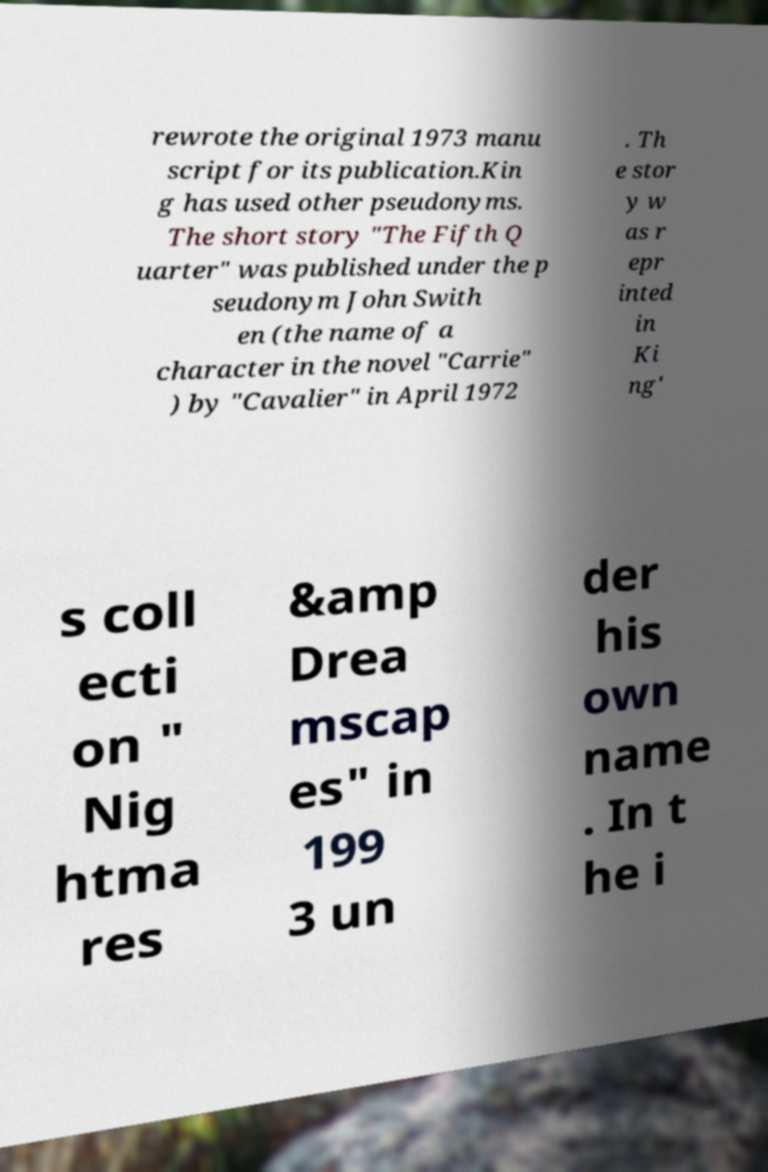What messages or text are displayed in this image? I need them in a readable, typed format. rewrote the original 1973 manu script for its publication.Kin g has used other pseudonyms. The short story "The Fifth Q uarter" was published under the p seudonym John Swith en (the name of a character in the novel "Carrie" ) by "Cavalier" in April 1972 . Th e stor y w as r epr inted in Ki ng' s coll ecti on " Nig htma res &amp Drea mscap es" in 199 3 un der his own name . In t he i 